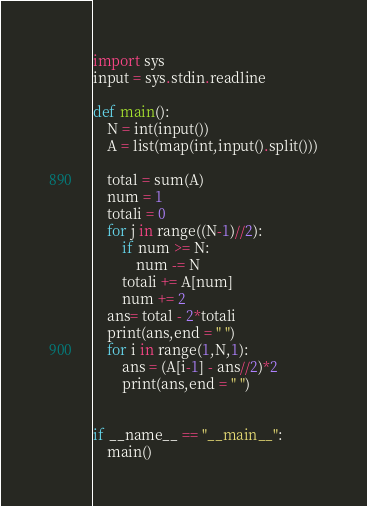<code> <loc_0><loc_0><loc_500><loc_500><_Python_>import sys
input = sys.stdin.readline

def main():
    N = int(input())
    A = list(map(int,input().split()))

    total = sum(A)
    num = 1
    totali = 0
    for j in range((N-1)//2):
        if num >= N:
            num -= N
        totali += A[num]
        num += 2
    ans= total - 2*totali
    print(ans,end = " ")
    for i in range(1,N,1):
        ans = (A[i-1] - ans//2)*2
        print(ans,end = " ")


if __name__ == "__main__":
    main()</code> 